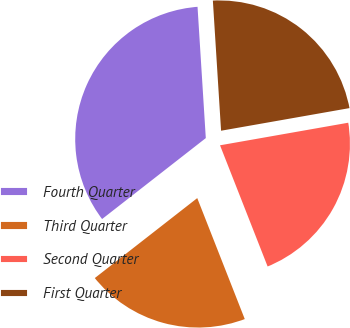Convert chart. <chart><loc_0><loc_0><loc_500><loc_500><pie_chart><fcel>Fourth Quarter<fcel>Third Quarter<fcel>Second Quarter<fcel>First Quarter<nl><fcel>34.55%<fcel>20.41%<fcel>21.82%<fcel>23.23%<nl></chart> 